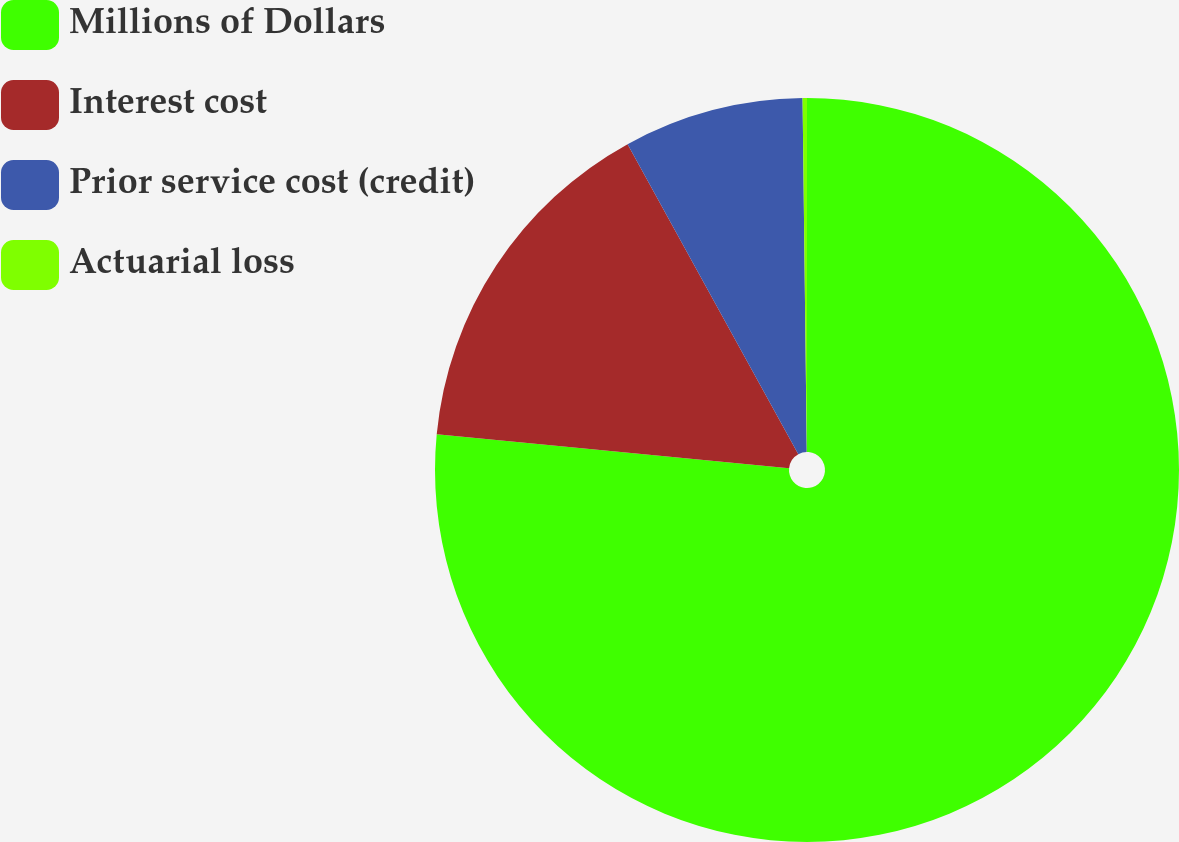<chart> <loc_0><loc_0><loc_500><loc_500><pie_chart><fcel>Millions of Dollars<fcel>Interest cost<fcel>Prior service cost (credit)<fcel>Actuarial loss<nl><fcel>76.53%<fcel>15.46%<fcel>7.82%<fcel>0.19%<nl></chart> 